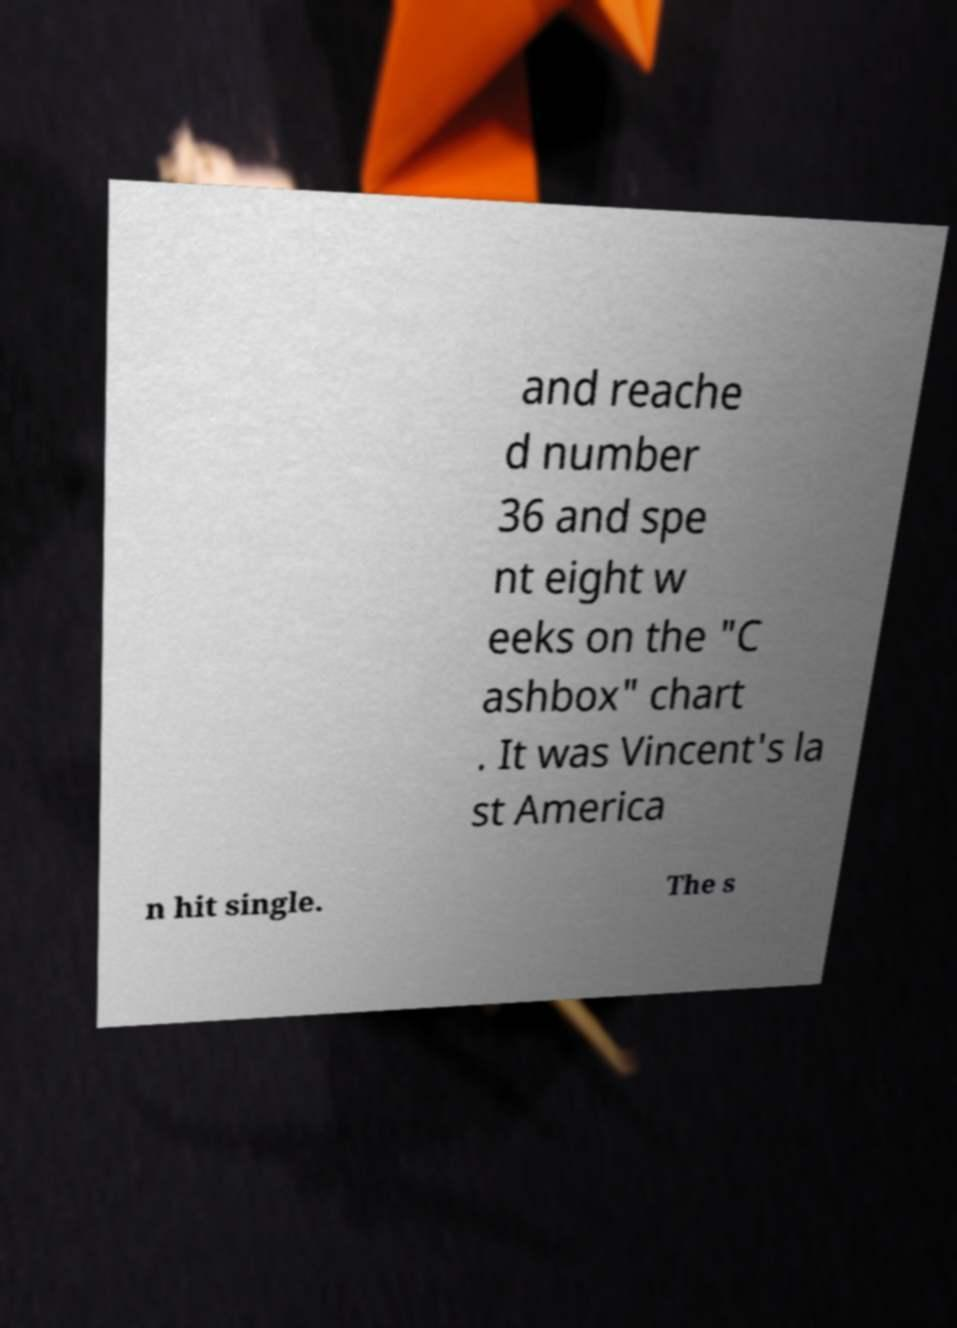Could you extract and type out the text from this image? and reache d number 36 and spe nt eight w eeks on the "C ashbox" chart . It was Vincent's la st America n hit single. The s 